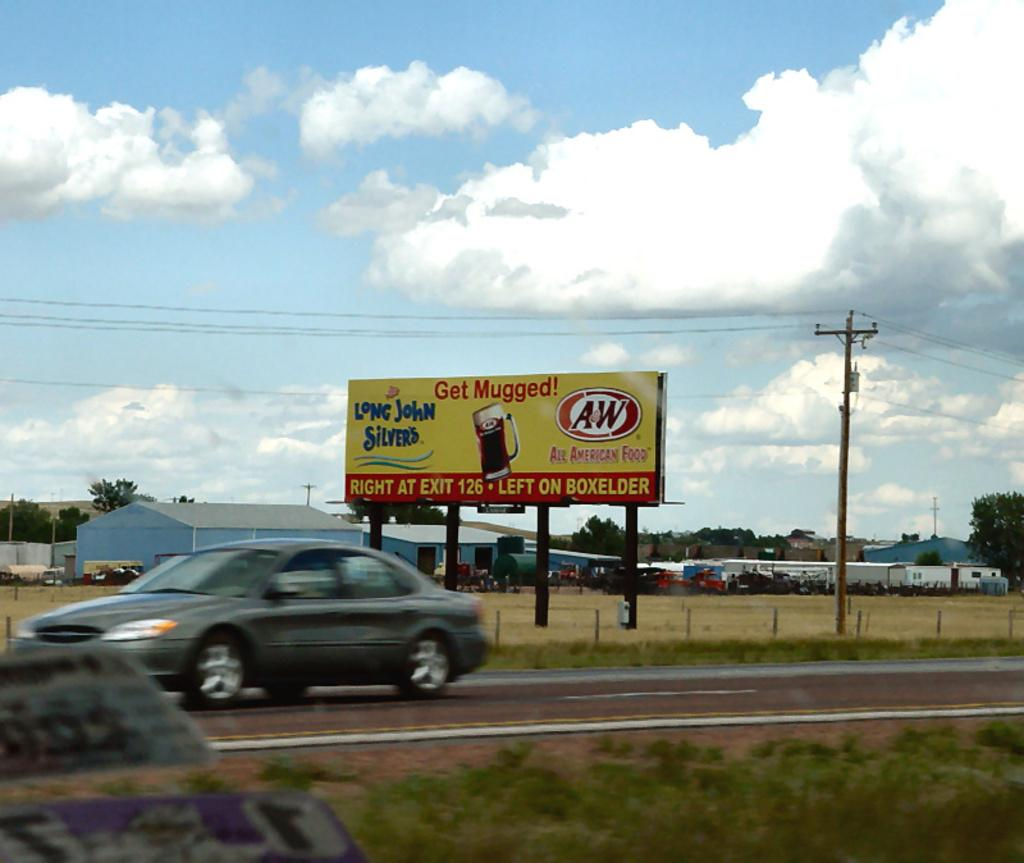<image>
Write a terse but informative summary of the picture. A bill board on the side of the road is for Long John Silvers restaurant. 